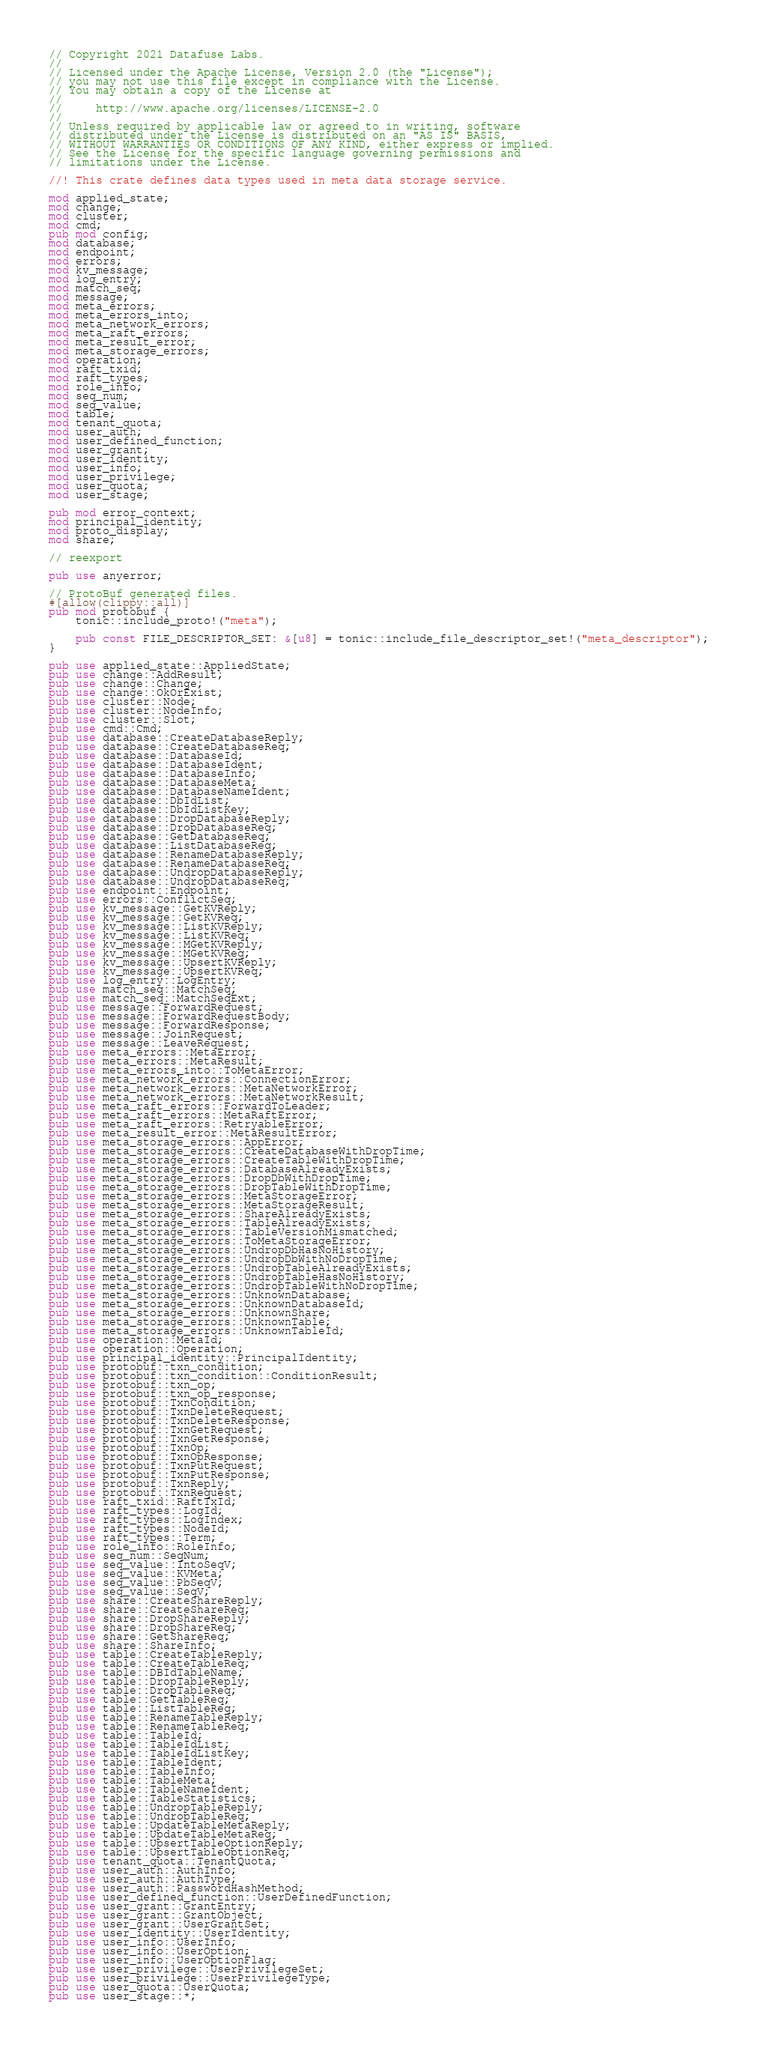<code> <loc_0><loc_0><loc_500><loc_500><_Rust_>// Copyright 2021 Datafuse Labs.
//
// Licensed under the Apache License, Version 2.0 (the "License");
// you may not use this file except in compliance with the License.
// You may obtain a copy of the License at
//
//     http://www.apache.org/licenses/LICENSE-2.0
//
// Unless required by applicable law or agreed to in writing, software
// distributed under the License is distributed on an "AS IS" BASIS,
// WITHOUT WARRANTIES OR CONDITIONS OF ANY KIND, either express or implied.
// See the License for the specific language governing permissions and
// limitations under the License.

//! This crate defines data types used in meta data storage service.

mod applied_state;
mod change;
mod cluster;
mod cmd;
pub mod config;
mod database;
mod endpoint;
mod errors;
mod kv_message;
mod log_entry;
mod match_seq;
mod message;
mod meta_errors;
mod meta_errors_into;
mod meta_network_errors;
mod meta_raft_errors;
mod meta_result_error;
mod meta_storage_errors;
mod operation;
mod raft_txid;
mod raft_types;
mod role_info;
mod seq_num;
mod seq_value;
mod table;
mod tenant_quota;
mod user_auth;
mod user_defined_function;
mod user_grant;
mod user_identity;
mod user_info;
mod user_privilege;
mod user_quota;
mod user_stage;

pub mod error_context;
mod principal_identity;
mod proto_display;
mod share;

// reexport

pub use anyerror;

// ProtoBuf generated files.
#[allow(clippy::all)]
pub mod protobuf {
    tonic::include_proto!("meta");

    pub const FILE_DESCRIPTOR_SET: &[u8] = tonic::include_file_descriptor_set!("meta_descriptor");
}

pub use applied_state::AppliedState;
pub use change::AddResult;
pub use change::Change;
pub use change::OkOrExist;
pub use cluster::Node;
pub use cluster::NodeInfo;
pub use cluster::Slot;
pub use cmd::Cmd;
pub use database::CreateDatabaseReply;
pub use database::CreateDatabaseReq;
pub use database::DatabaseId;
pub use database::DatabaseIdent;
pub use database::DatabaseInfo;
pub use database::DatabaseMeta;
pub use database::DatabaseNameIdent;
pub use database::DbIdList;
pub use database::DbIdListKey;
pub use database::DropDatabaseReply;
pub use database::DropDatabaseReq;
pub use database::GetDatabaseReq;
pub use database::ListDatabaseReq;
pub use database::RenameDatabaseReply;
pub use database::RenameDatabaseReq;
pub use database::UndropDatabaseReply;
pub use database::UndropDatabaseReq;
pub use endpoint::Endpoint;
pub use errors::ConflictSeq;
pub use kv_message::GetKVReply;
pub use kv_message::GetKVReq;
pub use kv_message::ListKVReply;
pub use kv_message::ListKVReq;
pub use kv_message::MGetKVReply;
pub use kv_message::MGetKVReq;
pub use kv_message::UpsertKVReply;
pub use kv_message::UpsertKVReq;
pub use log_entry::LogEntry;
pub use match_seq::MatchSeq;
pub use match_seq::MatchSeqExt;
pub use message::ForwardRequest;
pub use message::ForwardRequestBody;
pub use message::ForwardResponse;
pub use message::JoinRequest;
pub use message::LeaveRequest;
pub use meta_errors::MetaError;
pub use meta_errors::MetaResult;
pub use meta_errors_into::ToMetaError;
pub use meta_network_errors::ConnectionError;
pub use meta_network_errors::MetaNetworkError;
pub use meta_network_errors::MetaNetworkResult;
pub use meta_raft_errors::ForwardToLeader;
pub use meta_raft_errors::MetaRaftError;
pub use meta_raft_errors::RetryableError;
pub use meta_result_error::MetaResultError;
pub use meta_storage_errors::AppError;
pub use meta_storage_errors::CreateDatabaseWithDropTime;
pub use meta_storage_errors::CreateTableWithDropTime;
pub use meta_storage_errors::DatabaseAlreadyExists;
pub use meta_storage_errors::DropDbWithDropTime;
pub use meta_storage_errors::DropTableWithDropTime;
pub use meta_storage_errors::MetaStorageError;
pub use meta_storage_errors::MetaStorageResult;
pub use meta_storage_errors::ShareAlreadyExists;
pub use meta_storage_errors::TableAlreadyExists;
pub use meta_storage_errors::TableVersionMismatched;
pub use meta_storage_errors::ToMetaStorageError;
pub use meta_storage_errors::UndropDbHasNoHistory;
pub use meta_storage_errors::UndropDbWithNoDropTime;
pub use meta_storage_errors::UndropTableAlreadyExists;
pub use meta_storage_errors::UndropTableHasNoHistory;
pub use meta_storage_errors::UndropTableWithNoDropTime;
pub use meta_storage_errors::UnknownDatabase;
pub use meta_storage_errors::UnknownDatabaseId;
pub use meta_storage_errors::UnknownShare;
pub use meta_storage_errors::UnknownTable;
pub use meta_storage_errors::UnknownTableId;
pub use operation::MetaId;
pub use operation::Operation;
pub use principal_identity::PrincipalIdentity;
pub use protobuf::txn_condition;
pub use protobuf::txn_condition::ConditionResult;
pub use protobuf::txn_op;
pub use protobuf::txn_op_response;
pub use protobuf::TxnCondition;
pub use protobuf::TxnDeleteRequest;
pub use protobuf::TxnDeleteResponse;
pub use protobuf::TxnGetRequest;
pub use protobuf::TxnGetResponse;
pub use protobuf::TxnOp;
pub use protobuf::TxnOpResponse;
pub use protobuf::TxnPutRequest;
pub use protobuf::TxnPutResponse;
pub use protobuf::TxnReply;
pub use protobuf::TxnRequest;
pub use raft_txid::RaftTxId;
pub use raft_types::LogId;
pub use raft_types::LogIndex;
pub use raft_types::NodeId;
pub use raft_types::Term;
pub use role_info::RoleInfo;
pub use seq_num::SeqNum;
pub use seq_value::IntoSeqV;
pub use seq_value::KVMeta;
pub use seq_value::PbSeqV;
pub use seq_value::SeqV;
pub use share::CreateShareReply;
pub use share::CreateShareReq;
pub use share::DropShareReply;
pub use share::DropShareReq;
pub use share::GetShareReq;
pub use share::ShareInfo;
pub use table::CreateTableReply;
pub use table::CreateTableReq;
pub use table::DBIdTableName;
pub use table::DropTableReply;
pub use table::DropTableReq;
pub use table::GetTableReq;
pub use table::ListTableReq;
pub use table::RenameTableReply;
pub use table::RenameTableReq;
pub use table::TableId;
pub use table::TableIdList;
pub use table::TableIdListKey;
pub use table::TableIdent;
pub use table::TableInfo;
pub use table::TableMeta;
pub use table::TableNameIdent;
pub use table::TableStatistics;
pub use table::UndropTableReply;
pub use table::UndropTableReq;
pub use table::UpdateTableMetaReply;
pub use table::UpdateTableMetaReq;
pub use table::UpsertTableOptionReply;
pub use table::UpsertTableOptionReq;
pub use tenant_quota::TenantQuota;
pub use user_auth::AuthInfo;
pub use user_auth::AuthType;
pub use user_auth::PasswordHashMethod;
pub use user_defined_function::UserDefinedFunction;
pub use user_grant::GrantEntry;
pub use user_grant::GrantObject;
pub use user_grant::UserGrantSet;
pub use user_identity::UserIdentity;
pub use user_info::UserInfo;
pub use user_info::UserOption;
pub use user_info::UserOptionFlag;
pub use user_privilege::UserPrivilegeSet;
pub use user_privilege::UserPrivilegeType;
pub use user_quota::UserQuota;
pub use user_stage::*;
</code> 